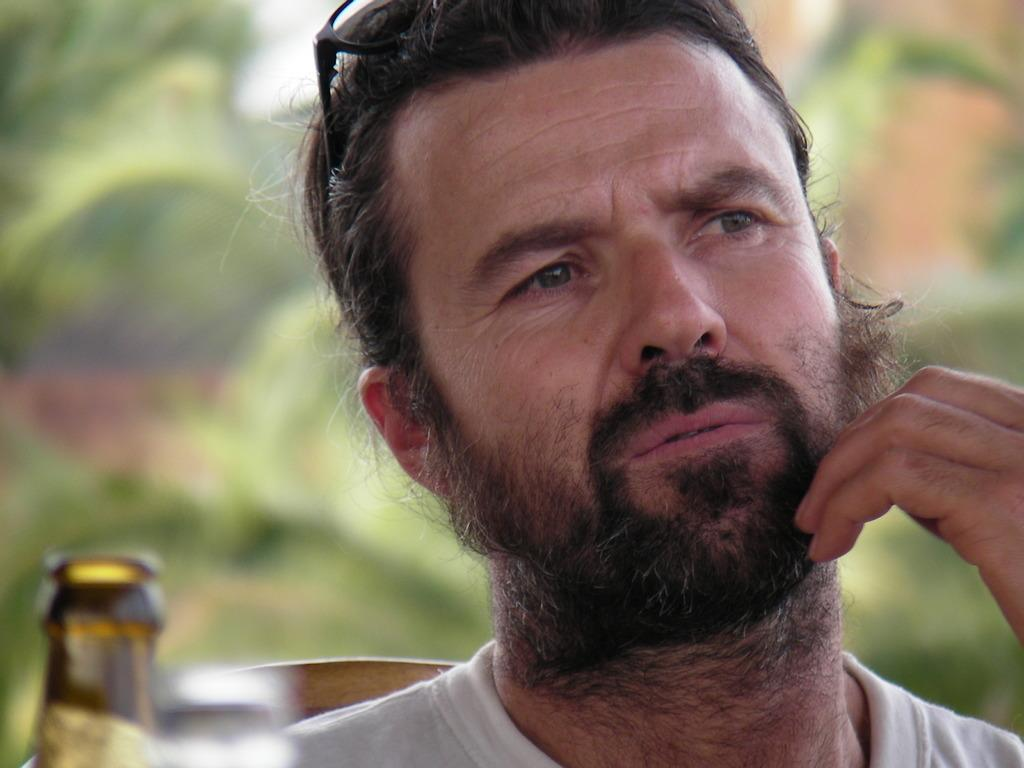Who is present in the image? There is a man in the image. What is the man wearing? The man is wearing clothes. What object can be seen in the image besides the man? There is a bottle, a chair, and spectacles in the image. What is the condition of the background in the image? The background of the image is blurred. What type of instrument can be seen being played by the man in the image? There is no instrument present in the image, and the man is not playing any instrument. 